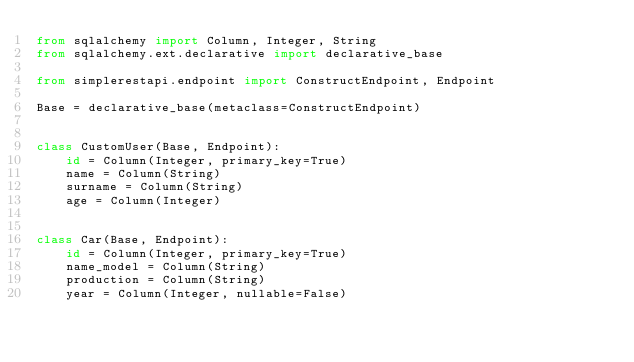<code> <loc_0><loc_0><loc_500><loc_500><_Python_>from sqlalchemy import Column, Integer, String
from sqlalchemy.ext.declarative import declarative_base

from simplerestapi.endpoint import ConstructEndpoint, Endpoint

Base = declarative_base(metaclass=ConstructEndpoint)


class CustomUser(Base, Endpoint):
    id = Column(Integer, primary_key=True)
    name = Column(String)
    surname = Column(String)
    age = Column(Integer)


class Car(Base, Endpoint):
    id = Column(Integer, primary_key=True)
    name_model = Column(String)
    production = Column(String)
    year = Column(Integer, nullable=False)
</code> 